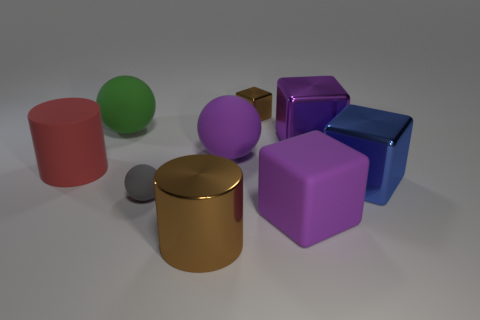The object that is the same color as the metal cylinder is what size?
Keep it short and to the point. Small. Do the blue metallic block and the purple shiny cube have the same size?
Offer a terse response. Yes. Is the number of large green rubber objects that are in front of the brown shiny cylinder greater than the number of rubber balls behind the big red object?
Provide a short and direct response. No. How many other things are the same size as the shiny cylinder?
Offer a terse response. 6. There is a large cylinder that is on the left side of the big brown cylinder; is its color the same as the large metallic cylinder?
Your answer should be compact. No. Is the number of blue things in front of the matte block greater than the number of big green rubber objects?
Your answer should be very brief. No. Are there any other things that are the same color as the big shiny cylinder?
Provide a succinct answer. Yes. What shape is the purple rubber object right of the brown metallic object that is behind the red rubber cylinder?
Ensure brevity in your answer.  Cube. Is the number of small cyan shiny blocks greater than the number of small rubber spheres?
Provide a short and direct response. No. What number of large things are both on the left side of the tiny brown metal cube and in front of the small rubber ball?
Ensure brevity in your answer.  1. 